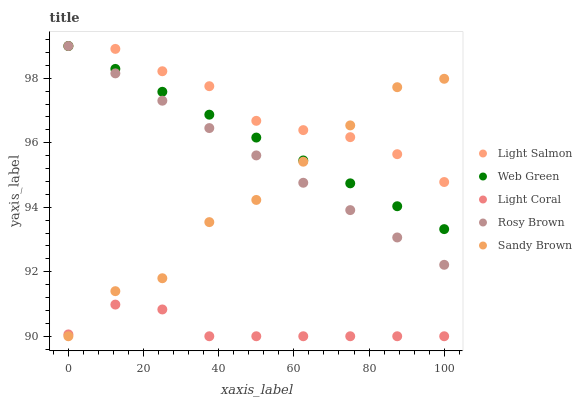Does Light Coral have the minimum area under the curve?
Answer yes or no. Yes. Does Light Salmon have the maximum area under the curve?
Answer yes or no. Yes. Does Rosy Brown have the minimum area under the curve?
Answer yes or no. No. Does Rosy Brown have the maximum area under the curve?
Answer yes or no. No. Is Web Green the smoothest?
Answer yes or no. Yes. Is Sandy Brown the roughest?
Answer yes or no. Yes. Is Light Salmon the smoothest?
Answer yes or no. No. Is Light Salmon the roughest?
Answer yes or no. No. Does Light Coral have the lowest value?
Answer yes or no. Yes. Does Rosy Brown have the lowest value?
Answer yes or no. No. Does Web Green have the highest value?
Answer yes or no. Yes. Does Sandy Brown have the highest value?
Answer yes or no. No. Is Light Coral less than Light Salmon?
Answer yes or no. Yes. Is Rosy Brown greater than Light Coral?
Answer yes or no. Yes. Does Light Salmon intersect Rosy Brown?
Answer yes or no. Yes. Is Light Salmon less than Rosy Brown?
Answer yes or no. No. Is Light Salmon greater than Rosy Brown?
Answer yes or no. No. Does Light Coral intersect Light Salmon?
Answer yes or no. No. 